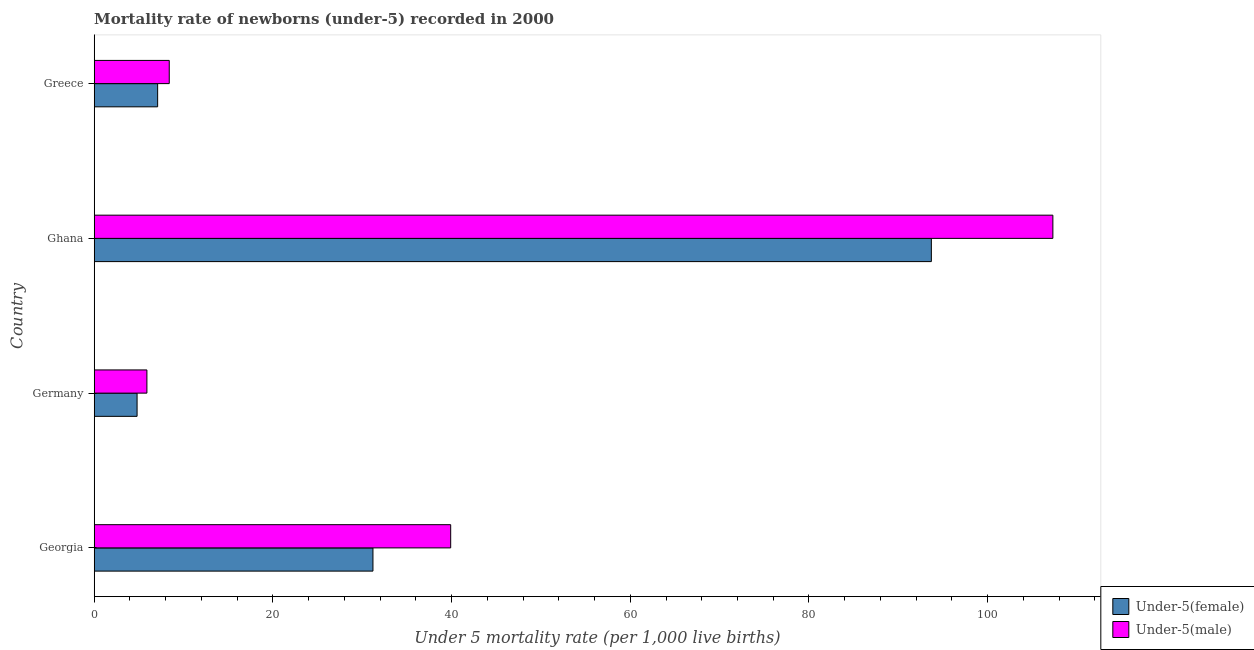How many different coloured bars are there?
Make the answer very short. 2. How many bars are there on the 3rd tick from the bottom?
Provide a short and direct response. 2. What is the label of the 3rd group of bars from the top?
Provide a short and direct response. Germany. What is the under-5 male mortality rate in Ghana?
Your answer should be compact. 107.3. Across all countries, what is the maximum under-5 female mortality rate?
Your answer should be very brief. 93.7. In which country was the under-5 female mortality rate minimum?
Ensure brevity in your answer.  Germany. What is the total under-5 female mortality rate in the graph?
Give a very brief answer. 136.8. What is the difference between the under-5 female mortality rate in Ghana and that in Greece?
Ensure brevity in your answer.  86.6. What is the difference between the under-5 male mortality rate in Georgia and the under-5 female mortality rate in Greece?
Offer a very short reply. 32.8. What is the average under-5 male mortality rate per country?
Your answer should be compact. 40.38. What is the ratio of the under-5 female mortality rate in Germany to that in Greece?
Make the answer very short. 0.68. Is the under-5 male mortality rate in Germany less than that in Greece?
Your response must be concise. Yes. Is the difference between the under-5 male mortality rate in Georgia and Greece greater than the difference between the under-5 female mortality rate in Georgia and Greece?
Your answer should be very brief. Yes. What is the difference between the highest and the second highest under-5 male mortality rate?
Offer a very short reply. 67.4. What is the difference between the highest and the lowest under-5 male mortality rate?
Keep it short and to the point. 101.4. Is the sum of the under-5 female mortality rate in Georgia and Ghana greater than the maximum under-5 male mortality rate across all countries?
Give a very brief answer. Yes. What does the 1st bar from the top in Ghana represents?
Offer a terse response. Under-5(male). What does the 1st bar from the bottom in Georgia represents?
Offer a very short reply. Under-5(female). How many bars are there?
Give a very brief answer. 8. Are the values on the major ticks of X-axis written in scientific E-notation?
Provide a short and direct response. No. Does the graph contain grids?
Make the answer very short. No. What is the title of the graph?
Give a very brief answer. Mortality rate of newborns (under-5) recorded in 2000. Does "Mobile cellular" appear as one of the legend labels in the graph?
Keep it short and to the point. No. What is the label or title of the X-axis?
Your answer should be very brief. Under 5 mortality rate (per 1,0 live births). What is the label or title of the Y-axis?
Provide a short and direct response. Country. What is the Under 5 mortality rate (per 1,000 live births) in Under-5(female) in Georgia?
Your answer should be very brief. 31.2. What is the Under 5 mortality rate (per 1,000 live births) in Under-5(male) in Georgia?
Provide a succinct answer. 39.9. What is the Under 5 mortality rate (per 1,000 live births) of Under-5(male) in Germany?
Ensure brevity in your answer.  5.9. What is the Under 5 mortality rate (per 1,000 live births) in Under-5(female) in Ghana?
Offer a very short reply. 93.7. What is the Under 5 mortality rate (per 1,000 live births) of Under-5(male) in Ghana?
Provide a succinct answer. 107.3. What is the Under 5 mortality rate (per 1,000 live births) of Under-5(female) in Greece?
Your response must be concise. 7.1. What is the Under 5 mortality rate (per 1,000 live births) in Under-5(male) in Greece?
Your response must be concise. 8.4. Across all countries, what is the maximum Under 5 mortality rate (per 1,000 live births) of Under-5(female)?
Your answer should be compact. 93.7. Across all countries, what is the maximum Under 5 mortality rate (per 1,000 live births) of Under-5(male)?
Offer a terse response. 107.3. What is the total Under 5 mortality rate (per 1,000 live births) of Under-5(female) in the graph?
Ensure brevity in your answer.  136.8. What is the total Under 5 mortality rate (per 1,000 live births) in Under-5(male) in the graph?
Provide a succinct answer. 161.5. What is the difference between the Under 5 mortality rate (per 1,000 live births) in Under-5(female) in Georgia and that in Germany?
Provide a short and direct response. 26.4. What is the difference between the Under 5 mortality rate (per 1,000 live births) of Under-5(female) in Georgia and that in Ghana?
Provide a succinct answer. -62.5. What is the difference between the Under 5 mortality rate (per 1,000 live births) in Under-5(male) in Georgia and that in Ghana?
Your answer should be compact. -67.4. What is the difference between the Under 5 mortality rate (per 1,000 live births) of Under-5(female) in Georgia and that in Greece?
Your answer should be very brief. 24.1. What is the difference between the Under 5 mortality rate (per 1,000 live births) of Under-5(male) in Georgia and that in Greece?
Give a very brief answer. 31.5. What is the difference between the Under 5 mortality rate (per 1,000 live births) of Under-5(female) in Germany and that in Ghana?
Make the answer very short. -88.9. What is the difference between the Under 5 mortality rate (per 1,000 live births) in Under-5(male) in Germany and that in Ghana?
Ensure brevity in your answer.  -101.4. What is the difference between the Under 5 mortality rate (per 1,000 live births) in Under-5(female) in Ghana and that in Greece?
Give a very brief answer. 86.6. What is the difference between the Under 5 mortality rate (per 1,000 live births) of Under-5(male) in Ghana and that in Greece?
Offer a terse response. 98.9. What is the difference between the Under 5 mortality rate (per 1,000 live births) of Under-5(female) in Georgia and the Under 5 mortality rate (per 1,000 live births) of Under-5(male) in Germany?
Offer a very short reply. 25.3. What is the difference between the Under 5 mortality rate (per 1,000 live births) in Under-5(female) in Georgia and the Under 5 mortality rate (per 1,000 live births) in Under-5(male) in Ghana?
Offer a very short reply. -76.1. What is the difference between the Under 5 mortality rate (per 1,000 live births) of Under-5(female) in Georgia and the Under 5 mortality rate (per 1,000 live births) of Under-5(male) in Greece?
Give a very brief answer. 22.8. What is the difference between the Under 5 mortality rate (per 1,000 live births) of Under-5(female) in Germany and the Under 5 mortality rate (per 1,000 live births) of Under-5(male) in Ghana?
Offer a very short reply. -102.5. What is the difference between the Under 5 mortality rate (per 1,000 live births) in Under-5(female) in Germany and the Under 5 mortality rate (per 1,000 live births) in Under-5(male) in Greece?
Keep it short and to the point. -3.6. What is the difference between the Under 5 mortality rate (per 1,000 live births) in Under-5(female) in Ghana and the Under 5 mortality rate (per 1,000 live births) in Under-5(male) in Greece?
Your response must be concise. 85.3. What is the average Under 5 mortality rate (per 1,000 live births) in Under-5(female) per country?
Keep it short and to the point. 34.2. What is the average Under 5 mortality rate (per 1,000 live births) of Under-5(male) per country?
Offer a very short reply. 40.38. What is the difference between the Under 5 mortality rate (per 1,000 live births) in Under-5(female) and Under 5 mortality rate (per 1,000 live births) in Under-5(male) in Ghana?
Keep it short and to the point. -13.6. What is the ratio of the Under 5 mortality rate (per 1,000 live births) in Under-5(female) in Georgia to that in Germany?
Your answer should be very brief. 6.5. What is the ratio of the Under 5 mortality rate (per 1,000 live births) of Under-5(male) in Georgia to that in Germany?
Make the answer very short. 6.76. What is the ratio of the Under 5 mortality rate (per 1,000 live births) in Under-5(female) in Georgia to that in Ghana?
Your answer should be compact. 0.33. What is the ratio of the Under 5 mortality rate (per 1,000 live births) in Under-5(male) in Georgia to that in Ghana?
Give a very brief answer. 0.37. What is the ratio of the Under 5 mortality rate (per 1,000 live births) of Under-5(female) in Georgia to that in Greece?
Offer a terse response. 4.39. What is the ratio of the Under 5 mortality rate (per 1,000 live births) in Under-5(male) in Georgia to that in Greece?
Keep it short and to the point. 4.75. What is the ratio of the Under 5 mortality rate (per 1,000 live births) of Under-5(female) in Germany to that in Ghana?
Offer a terse response. 0.05. What is the ratio of the Under 5 mortality rate (per 1,000 live births) in Under-5(male) in Germany to that in Ghana?
Make the answer very short. 0.06. What is the ratio of the Under 5 mortality rate (per 1,000 live births) of Under-5(female) in Germany to that in Greece?
Your response must be concise. 0.68. What is the ratio of the Under 5 mortality rate (per 1,000 live births) in Under-5(male) in Germany to that in Greece?
Ensure brevity in your answer.  0.7. What is the ratio of the Under 5 mortality rate (per 1,000 live births) of Under-5(female) in Ghana to that in Greece?
Your response must be concise. 13.2. What is the ratio of the Under 5 mortality rate (per 1,000 live births) in Under-5(male) in Ghana to that in Greece?
Give a very brief answer. 12.77. What is the difference between the highest and the second highest Under 5 mortality rate (per 1,000 live births) of Under-5(female)?
Keep it short and to the point. 62.5. What is the difference between the highest and the second highest Under 5 mortality rate (per 1,000 live births) of Under-5(male)?
Make the answer very short. 67.4. What is the difference between the highest and the lowest Under 5 mortality rate (per 1,000 live births) of Under-5(female)?
Your answer should be compact. 88.9. What is the difference between the highest and the lowest Under 5 mortality rate (per 1,000 live births) in Under-5(male)?
Offer a very short reply. 101.4. 